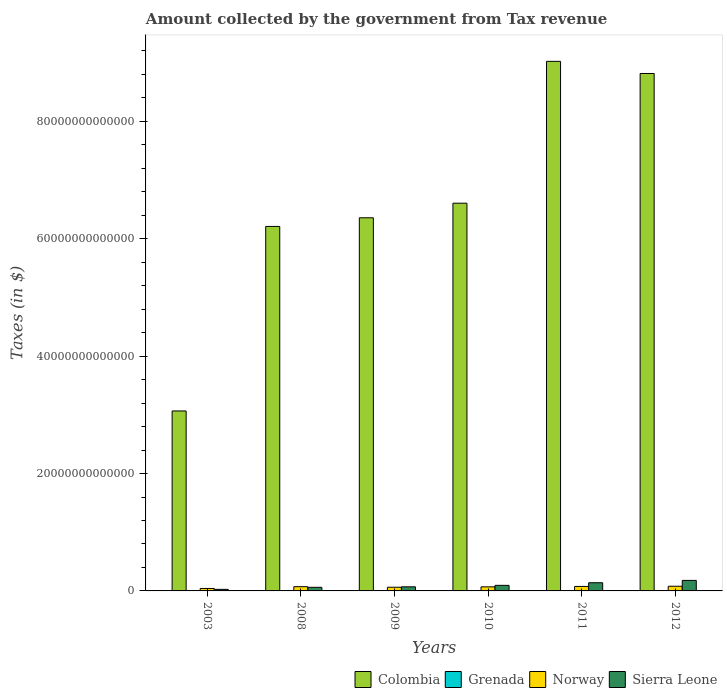How many different coloured bars are there?
Provide a succinct answer. 4. Are the number of bars per tick equal to the number of legend labels?
Keep it short and to the point. Yes. What is the amount collected by the government from tax revenue in Grenada in 2003?
Your answer should be very brief. 2.98e+08. Across all years, what is the maximum amount collected by the government from tax revenue in Norway?
Offer a terse response. 7.94e+11. Across all years, what is the minimum amount collected by the government from tax revenue in Norway?
Keep it short and to the point. 4.19e+11. What is the total amount collected by the government from tax revenue in Norway in the graph?
Your answer should be very brief. 4.02e+12. What is the difference between the amount collected by the government from tax revenue in Sierra Leone in 2008 and the amount collected by the government from tax revenue in Norway in 2009?
Keep it short and to the point. -1.29e+1. What is the average amount collected by the government from tax revenue in Colombia per year?
Your answer should be compact. 6.68e+13. In the year 2008, what is the difference between the amount collected by the government from tax revenue in Norway and amount collected by the government from tax revenue in Grenada?
Keep it short and to the point. 7.23e+11. In how many years, is the amount collected by the government from tax revenue in Sierra Leone greater than 84000000000000 $?
Offer a very short reply. 0. What is the ratio of the amount collected by the government from tax revenue in Grenada in 2008 to that in 2012?
Your answer should be very brief. 1.08. What is the difference between the highest and the second highest amount collected by the government from tax revenue in Grenada?
Your response must be concise. 3.06e+07. What is the difference between the highest and the lowest amount collected by the government from tax revenue in Colombia?
Give a very brief answer. 5.96e+13. Is the sum of the amount collected by the government from tax revenue in Grenada in 2009 and 2010 greater than the maximum amount collected by the government from tax revenue in Colombia across all years?
Provide a succinct answer. No. Is it the case that in every year, the sum of the amount collected by the government from tax revenue in Grenada and amount collected by the government from tax revenue in Sierra Leone is greater than the sum of amount collected by the government from tax revenue in Norway and amount collected by the government from tax revenue in Colombia?
Your answer should be compact. Yes. What does the 3rd bar from the left in 2009 represents?
Provide a succinct answer. Norway. How many bars are there?
Provide a succinct answer. 24. Are all the bars in the graph horizontal?
Make the answer very short. No. What is the difference between two consecutive major ticks on the Y-axis?
Offer a very short reply. 2.00e+13. Are the values on the major ticks of Y-axis written in scientific E-notation?
Make the answer very short. No. Does the graph contain grids?
Offer a terse response. No. How many legend labels are there?
Your response must be concise. 4. How are the legend labels stacked?
Make the answer very short. Horizontal. What is the title of the graph?
Offer a very short reply. Amount collected by the government from Tax revenue. What is the label or title of the Y-axis?
Your answer should be very brief. Taxes (in $). What is the Taxes (in $) of Colombia in 2003?
Ensure brevity in your answer.  3.07e+13. What is the Taxes (in $) in Grenada in 2003?
Ensure brevity in your answer.  2.98e+08. What is the Taxes (in $) of Norway in 2003?
Ensure brevity in your answer.  4.19e+11. What is the Taxes (in $) of Sierra Leone in 2003?
Provide a succinct answer. 2.68e+11. What is the Taxes (in $) of Colombia in 2008?
Your answer should be very brief. 6.21e+13. What is the Taxes (in $) of Grenada in 2008?
Offer a very short reply. 4.34e+08. What is the Taxes (in $) in Norway in 2008?
Keep it short and to the point. 7.24e+11. What is the Taxes (in $) of Sierra Leone in 2008?
Offer a very short reply. 6.13e+11. What is the Taxes (in $) in Colombia in 2009?
Keep it short and to the point. 6.36e+13. What is the Taxes (in $) of Grenada in 2009?
Give a very brief answer. 3.80e+08. What is the Taxes (in $) in Norway in 2009?
Your answer should be compact. 6.26e+11. What is the Taxes (in $) of Sierra Leone in 2009?
Your response must be concise. 6.99e+11. What is the Taxes (in $) in Colombia in 2010?
Offer a terse response. 6.61e+13. What is the Taxes (in $) in Grenada in 2010?
Keep it short and to the point. 3.90e+08. What is the Taxes (in $) in Norway in 2010?
Your response must be concise. 6.93e+11. What is the Taxes (in $) of Sierra Leone in 2010?
Ensure brevity in your answer.  9.48e+11. What is the Taxes (in $) of Colombia in 2011?
Offer a very short reply. 9.02e+13. What is the Taxes (in $) in Grenada in 2011?
Ensure brevity in your answer.  4.03e+08. What is the Taxes (in $) of Norway in 2011?
Offer a terse response. 7.65e+11. What is the Taxes (in $) in Sierra Leone in 2011?
Offer a very short reply. 1.39e+12. What is the Taxes (in $) of Colombia in 2012?
Ensure brevity in your answer.  8.82e+13. What is the Taxes (in $) in Grenada in 2012?
Make the answer very short. 4.03e+08. What is the Taxes (in $) in Norway in 2012?
Make the answer very short. 7.94e+11. What is the Taxes (in $) in Sierra Leone in 2012?
Your answer should be very brief. 1.79e+12. Across all years, what is the maximum Taxes (in $) in Colombia?
Offer a very short reply. 9.02e+13. Across all years, what is the maximum Taxes (in $) of Grenada?
Your answer should be compact. 4.34e+08. Across all years, what is the maximum Taxes (in $) in Norway?
Your response must be concise. 7.94e+11. Across all years, what is the maximum Taxes (in $) in Sierra Leone?
Provide a short and direct response. 1.79e+12. Across all years, what is the minimum Taxes (in $) in Colombia?
Make the answer very short. 3.07e+13. Across all years, what is the minimum Taxes (in $) of Grenada?
Make the answer very short. 2.98e+08. Across all years, what is the minimum Taxes (in $) of Norway?
Make the answer very short. 4.19e+11. Across all years, what is the minimum Taxes (in $) in Sierra Leone?
Offer a very short reply. 2.68e+11. What is the total Taxes (in $) of Colombia in the graph?
Your answer should be compact. 4.01e+14. What is the total Taxes (in $) in Grenada in the graph?
Your answer should be compact. 2.31e+09. What is the total Taxes (in $) of Norway in the graph?
Ensure brevity in your answer.  4.02e+12. What is the total Taxes (in $) in Sierra Leone in the graph?
Your answer should be compact. 5.72e+12. What is the difference between the Taxes (in $) of Colombia in 2003 and that in 2008?
Your answer should be compact. -3.14e+13. What is the difference between the Taxes (in $) in Grenada in 2003 and that in 2008?
Provide a succinct answer. -1.36e+08. What is the difference between the Taxes (in $) in Norway in 2003 and that in 2008?
Make the answer very short. -3.05e+11. What is the difference between the Taxes (in $) in Sierra Leone in 2003 and that in 2008?
Your response must be concise. -3.46e+11. What is the difference between the Taxes (in $) in Colombia in 2003 and that in 2009?
Your response must be concise. -3.29e+13. What is the difference between the Taxes (in $) in Grenada in 2003 and that in 2009?
Ensure brevity in your answer.  -8.16e+07. What is the difference between the Taxes (in $) of Norway in 2003 and that in 2009?
Your response must be concise. -2.07e+11. What is the difference between the Taxes (in $) of Sierra Leone in 2003 and that in 2009?
Offer a very short reply. -4.31e+11. What is the difference between the Taxes (in $) in Colombia in 2003 and that in 2010?
Keep it short and to the point. -3.54e+13. What is the difference between the Taxes (in $) of Grenada in 2003 and that in 2010?
Your answer should be compact. -9.16e+07. What is the difference between the Taxes (in $) of Norway in 2003 and that in 2010?
Your answer should be very brief. -2.74e+11. What is the difference between the Taxes (in $) of Sierra Leone in 2003 and that in 2010?
Your answer should be very brief. -6.80e+11. What is the difference between the Taxes (in $) in Colombia in 2003 and that in 2011?
Ensure brevity in your answer.  -5.96e+13. What is the difference between the Taxes (in $) in Grenada in 2003 and that in 2011?
Your response must be concise. -1.05e+08. What is the difference between the Taxes (in $) of Norway in 2003 and that in 2011?
Ensure brevity in your answer.  -3.46e+11. What is the difference between the Taxes (in $) in Sierra Leone in 2003 and that in 2011?
Give a very brief answer. -1.13e+12. What is the difference between the Taxes (in $) in Colombia in 2003 and that in 2012?
Your answer should be compact. -5.75e+13. What is the difference between the Taxes (in $) of Grenada in 2003 and that in 2012?
Offer a terse response. -1.05e+08. What is the difference between the Taxes (in $) of Norway in 2003 and that in 2012?
Your response must be concise. -3.75e+11. What is the difference between the Taxes (in $) of Sierra Leone in 2003 and that in 2012?
Your response must be concise. -1.53e+12. What is the difference between the Taxes (in $) in Colombia in 2008 and that in 2009?
Ensure brevity in your answer.  -1.47e+12. What is the difference between the Taxes (in $) of Grenada in 2008 and that in 2009?
Offer a terse response. 5.39e+07. What is the difference between the Taxes (in $) in Norway in 2008 and that in 2009?
Give a very brief answer. 9.71e+1. What is the difference between the Taxes (in $) of Sierra Leone in 2008 and that in 2009?
Your answer should be very brief. -8.54e+1. What is the difference between the Taxes (in $) of Colombia in 2008 and that in 2010?
Offer a terse response. -3.96e+12. What is the difference between the Taxes (in $) in Grenada in 2008 and that in 2010?
Your answer should be compact. 4.39e+07. What is the difference between the Taxes (in $) of Norway in 2008 and that in 2010?
Offer a very short reply. 3.08e+1. What is the difference between the Taxes (in $) of Sierra Leone in 2008 and that in 2010?
Offer a very short reply. -3.35e+11. What is the difference between the Taxes (in $) of Colombia in 2008 and that in 2011?
Offer a terse response. -2.81e+13. What is the difference between the Taxes (in $) of Grenada in 2008 and that in 2011?
Offer a very short reply. 3.08e+07. What is the difference between the Taxes (in $) of Norway in 2008 and that in 2011?
Make the answer very short. -4.12e+1. What is the difference between the Taxes (in $) of Sierra Leone in 2008 and that in 2011?
Provide a short and direct response. -7.80e+11. What is the difference between the Taxes (in $) in Colombia in 2008 and that in 2012?
Provide a succinct answer. -2.61e+13. What is the difference between the Taxes (in $) in Grenada in 2008 and that in 2012?
Offer a very short reply. 3.06e+07. What is the difference between the Taxes (in $) in Norway in 2008 and that in 2012?
Make the answer very short. -7.03e+1. What is the difference between the Taxes (in $) of Sierra Leone in 2008 and that in 2012?
Offer a terse response. -1.18e+12. What is the difference between the Taxes (in $) of Colombia in 2009 and that in 2010?
Make the answer very short. -2.49e+12. What is the difference between the Taxes (in $) of Grenada in 2009 and that in 2010?
Offer a terse response. -1.00e+07. What is the difference between the Taxes (in $) of Norway in 2009 and that in 2010?
Offer a very short reply. -6.63e+1. What is the difference between the Taxes (in $) of Sierra Leone in 2009 and that in 2010?
Ensure brevity in your answer.  -2.49e+11. What is the difference between the Taxes (in $) in Colombia in 2009 and that in 2011?
Offer a very short reply. -2.67e+13. What is the difference between the Taxes (in $) in Grenada in 2009 and that in 2011?
Keep it short and to the point. -2.31e+07. What is the difference between the Taxes (in $) in Norway in 2009 and that in 2011?
Offer a terse response. -1.38e+11. What is the difference between the Taxes (in $) of Sierra Leone in 2009 and that in 2011?
Offer a very short reply. -6.95e+11. What is the difference between the Taxes (in $) in Colombia in 2009 and that in 2012?
Give a very brief answer. -2.46e+13. What is the difference between the Taxes (in $) in Grenada in 2009 and that in 2012?
Ensure brevity in your answer.  -2.33e+07. What is the difference between the Taxes (in $) of Norway in 2009 and that in 2012?
Provide a short and direct response. -1.67e+11. What is the difference between the Taxes (in $) in Sierra Leone in 2009 and that in 2012?
Give a very brief answer. -1.09e+12. What is the difference between the Taxes (in $) in Colombia in 2010 and that in 2011?
Provide a short and direct response. -2.42e+13. What is the difference between the Taxes (in $) in Grenada in 2010 and that in 2011?
Offer a very short reply. -1.31e+07. What is the difference between the Taxes (in $) in Norway in 2010 and that in 2011?
Ensure brevity in your answer.  -7.20e+1. What is the difference between the Taxes (in $) of Sierra Leone in 2010 and that in 2011?
Keep it short and to the point. -4.45e+11. What is the difference between the Taxes (in $) of Colombia in 2010 and that in 2012?
Your answer should be compact. -2.21e+13. What is the difference between the Taxes (in $) in Grenada in 2010 and that in 2012?
Provide a short and direct response. -1.33e+07. What is the difference between the Taxes (in $) of Norway in 2010 and that in 2012?
Your answer should be very brief. -1.01e+11. What is the difference between the Taxes (in $) of Sierra Leone in 2010 and that in 2012?
Provide a short and direct response. -8.45e+11. What is the difference between the Taxes (in $) in Colombia in 2011 and that in 2012?
Give a very brief answer. 2.07e+12. What is the difference between the Taxes (in $) of Grenada in 2011 and that in 2012?
Make the answer very short. -2.00e+05. What is the difference between the Taxes (in $) of Norway in 2011 and that in 2012?
Your answer should be very brief. -2.91e+1. What is the difference between the Taxes (in $) of Sierra Leone in 2011 and that in 2012?
Provide a short and direct response. -4.00e+11. What is the difference between the Taxes (in $) of Colombia in 2003 and the Taxes (in $) of Grenada in 2008?
Your answer should be very brief. 3.07e+13. What is the difference between the Taxes (in $) in Colombia in 2003 and the Taxes (in $) in Norway in 2008?
Make the answer very short. 2.99e+13. What is the difference between the Taxes (in $) in Colombia in 2003 and the Taxes (in $) in Sierra Leone in 2008?
Provide a short and direct response. 3.00e+13. What is the difference between the Taxes (in $) of Grenada in 2003 and the Taxes (in $) of Norway in 2008?
Ensure brevity in your answer.  -7.23e+11. What is the difference between the Taxes (in $) in Grenada in 2003 and the Taxes (in $) in Sierra Leone in 2008?
Offer a terse response. -6.13e+11. What is the difference between the Taxes (in $) in Norway in 2003 and the Taxes (in $) in Sierra Leone in 2008?
Your response must be concise. -1.95e+11. What is the difference between the Taxes (in $) in Colombia in 2003 and the Taxes (in $) in Grenada in 2009?
Offer a very short reply. 3.07e+13. What is the difference between the Taxes (in $) of Colombia in 2003 and the Taxes (in $) of Norway in 2009?
Your answer should be very brief. 3.00e+13. What is the difference between the Taxes (in $) in Colombia in 2003 and the Taxes (in $) in Sierra Leone in 2009?
Give a very brief answer. 3.00e+13. What is the difference between the Taxes (in $) of Grenada in 2003 and the Taxes (in $) of Norway in 2009?
Offer a terse response. -6.26e+11. What is the difference between the Taxes (in $) of Grenada in 2003 and the Taxes (in $) of Sierra Leone in 2009?
Give a very brief answer. -6.99e+11. What is the difference between the Taxes (in $) in Norway in 2003 and the Taxes (in $) in Sierra Leone in 2009?
Your answer should be compact. -2.80e+11. What is the difference between the Taxes (in $) of Colombia in 2003 and the Taxes (in $) of Grenada in 2010?
Provide a succinct answer. 3.07e+13. What is the difference between the Taxes (in $) in Colombia in 2003 and the Taxes (in $) in Norway in 2010?
Your response must be concise. 3.00e+13. What is the difference between the Taxes (in $) of Colombia in 2003 and the Taxes (in $) of Sierra Leone in 2010?
Provide a succinct answer. 2.97e+13. What is the difference between the Taxes (in $) of Grenada in 2003 and the Taxes (in $) of Norway in 2010?
Keep it short and to the point. -6.92e+11. What is the difference between the Taxes (in $) of Grenada in 2003 and the Taxes (in $) of Sierra Leone in 2010?
Provide a succinct answer. -9.48e+11. What is the difference between the Taxes (in $) of Norway in 2003 and the Taxes (in $) of Sierra Leone in 2010?
Offer a terse response. -5.29e+11. What is the difference between the Taxes (in $) in Colombia in 2003 and the Taxes (in $) in Grenada in 2011?
Your answer should be very brief. 3.07e+13. What is the difference between the Taxes (in $) of Colombia in 2003 and the Taxes (in $) of Norway in 2011?
Your response must be concise. 2.99e+13. What is the difference between the Taxes (in $) of Colombia in 2003 and the Taxes (in $) of Sierra Leone in 2011?
Give a very brief answer. 2.93e+13. What is the difference between the Taxes (in $) of Grenada in 2003 and the Taxes (in $) of Norway in 2011?
Keep it short and to the point. -7.64e+11. What is the difference between the Taxes (in $) of Grenada in 2003 and the Taxes (in $) of Sierra Leone in 2011?
Give a very brief answer. -1.39e+12. What is the difference between the Taxes (in $) of Norway in 2003 and the Taxes (in $) of Sierra Leone in 2011?
Your answer should be very brief. -9.75e+11. What is the difference between the Taxes (in $) in Colombia in 2003 and the Taxes (in $) in Grenada in 2012?
Provide a short and direct response. 3.07e+13. What is the difference between the Taxes (in $) in Colombia in 2003 and the Taxes (in $) in Norway in 2012?
Your answer should be compact. 2.99e+13. What is the difference between the Taxes (in $) in Colombia in 2003 and the Taxes (in $) in Sierra Leone in 2012?
Provide a succinct answer. 2.89e+13. What is the difference between the Taxes (in $) of Grenada in 2003 and the Taxes (in $) of Norway in 2012?
Keep it short and to the point. -7.93e+11. What is the difference between the Taxes (in $) of Grenada in 2003 and the Taxes (in $) of Sierra Leone in 2012?
Keep it short and to the point. -1.79e+12. What is the difference between the Taxes (in $) of Norway in 2003 and the Taxes (in $) of Sierra Leone in 2012?
Your response must be concise. -1.37e+12. What is the difference between the Taxes (in $) in Colombia in 2008 and the Taxes (in $) in Grenada in 2009?
Provide a short and direct response. 6.21e+13. What is the difference between the Taxes (in $) of Colombia in 2008 and the Taxes (in $) of Norway in 2009?
Provide a succinct answer. 6.15e+13. What is the difference between the Taxes (in $) in Colombia in 2008 and the Taxes (in $) in Sierra Leone in 2009?
Offer a terse response. 6.14e+13. What is the difference between the Taxes (in $) in Grenada in 2008 and the Taxes (in $) in Norway in 2009?
Provide a short and direct response. -6.26e+11. What is the difference between the Taxes (in $) of Grenada in 2008 and the Taxes (in $) of Sierra Leone in 2009?
Offer a very short reply. -6.98e+11. What is the difference between the Taxes (in $) in Norway in 2008 and the Taxes (in $) in Sierra Leone in 2009?
Provide a succinct answer. 2.46e+1. What is the difference between the Taxes (in $) in Colombia in 2008 and the Taxes (in $) in Grenada in 2010?
Offer a very short reply. 6.21e+13. What is the difference between the Taxes (in $) in Colombia in 2008 and the Taxes (in $) in Norway in 2010?
Your answer should be compact. 6.14e+13. What is the difference between the Taxes (in $) of Colombia in 2008 and the Taxes (in $) of Sierra Leone in 2010?
Provide a short and direct response. 6.12e+13. What is the difference between the Taxes (in $) in Grenada in 2008 and the Taxes (in $) in Norway in 2010?
Provide a succinct answer. -6.92e+11. What is the difference between the Taxes (in $) of Grenada in 2008 and the Taxes (in $) of Sierra Leone in 2010?
Provide a short and direct response. -9.48e+11. What is the difference between the Taxes (in $) of Norway in 2008 and the Taxes (in $) of Sierra Leone in 2010?
Make the answer very short. -2.25e+11. What is the difference between the Taxes (in $) of Colombia in 2008 and the Taxes (in $) of Grenada in 2011?
Your response must be concise. 6.21e+13. What is the difference between the Taxes (in $) of Colombia in 2008 and the Taxes (in $) of Norway in 2011?
Offer a terse response. 6.13e+13. What is the difference between the Taxes (in $) of Colombia in 2008 and the Taxes (in $) of Sierra Leone in 2011?
Offer a very short reply. 6.07e+13. What is the difference between the Taxes (in $) of Grenada in 2008 and the Taxes (in $) of Norway in 2011?
Offer a terse response. -7.64e+11. What is the difference between the Taxes (in $) in Grenada in 2008 and the Taxes (in $) in Sierra Leone in 2011?
Your answer should be compact. -1.39e+12. What is the difference between the Taxes (in $) of Norway in 2008 and the Taxes (in $) of Sierra Leone in 2011?
Your answer should be very brief. -6.70e+11. What is the difference between the Taxes (in $) in Colombia in 2008 and the Taxes (in $) in Grenada in 2012?
Provide a short and direct response. 6.21e+13. What is the difference between the Taxes (in $) in Colombia in 2008 and the Taxes (in $) in Norway in 2012?
Provide a short and direct response. 6.13e+13. What is the difference between the Taxes (in $) of Colombia in 2008 and the Taxes (in $) of Sierra Leone in 2012?
Your answer should be very brief. 6.03e+13. What is the difference between the Taxes (in $) in Grenada in 2008 and the Taxes (in $) in Norway in 2012?
Give a very brief answer. -7.93e+11. What is the difference between the Taxes (in $) of Grenada in 2008 and the Taxes (in $) of Sierra Leone in 2012?
Provide a short and direct response. -1.79e+12. What is the difference between the Taxes (in $) of Norway in 2008 and the Taxes (in $) of Sierra Leone in 2012?
Your response must be concise. -1.07e+12. What is the difference between the Taxes (in $) of Colombia in 2009 and the Taxes (in $) of Grenada in 2010?
Offer a terse response. 6.36e+13. What is the difference between the Taxes (in $) of Colombia in 2009 and the Taxes (in $) of Norway in 2010?
Provide a succinct answer. 6.29e+13. What is the difference between the Taxes (in $) of Colombia in 2009 and the Taxes (in $) of Sierra Leone in 2010?
Make the answer very short. 6.26e+13. What is the difference between the Taxes (in $) of Grenada in 2009 and the Taxes (in $) of Norway in 2010?
Provide a short and direct response. -6.92e+11. What is the difference between the Taxes (in $) in Grenada in 2009 and the Taxes (in $) in Sierra Leone in 2010?
Your response must be concise. -9.48e+11. What is the difference between the Taxes (in $) of Norway in 2009 and the Taxes (in $) of Sierra Leone in 2010?
Ensure brevity in your answer.  -3.22e+11. What is the difference between the Taxes (in $) of Colombia in 2009 and the Taxes (in $) of Grenada in 2011?
Give a very brief answer. 6.36e+13. What is the difference between the Taxes (in $) of Colombia in 2009 and the Taxes (in $) of Norway in 2011?
Keep it short and to the point. 6.28e+13. What is the difference between the Taxes (in $) of Colombia in 2009 and the Taxes (in $) of Sierra Leone in 2011?
Give a very brief answer. 6.22e+13. What is the difference between the Taxes (in $) in Grenada in 2009 and the Taxes (in $) in Norway in 2011?
Ensure brevity in your answer.  -7.64e+11. What is the difference between the Taxes (in $) of Grenada in 2009 and the Taxes (in $) of Sierra Leone in 2011?
Give a very brief answer. -1.39e+12. What is the difference between the Taxes (in $) of Norway in 2009 and the Taxes (in $) of Sierra Leone in 2011?
Give a very brief answer. -7.67e+11. What is the difference between the Taxes (in $) of Colombia in 2009 and the Taxes (in $) of Grenada in 2012?
Keep it short and to the point. 6.36e+13. What is the difference between the Taxes (in $) of Colombia in 2009 and the Taxes (in $) of Norway in 2012?
Ensure brevity in your answer.  6.28e+13. What is the difference between the Taxes (in $) of Colombia in 2009 and the Taxes (in $) of Sierra Leone in 2012?
Your response must be concise. 6.18e+13. What is the difference between the Taxes (in $) in Grenada in 2009 and the Taxes (in $) in Norway in 2012?
Provide a short and direct response. -7.93e+11. What is the difference between the Taxes (in $) of Grenada in 2009 and the Taxes (in $) of Sierra Leone in 2012?
Provide a succinct answer. -1.79e+12. What is the difference between the Taxes (in $) in Norway in 2009 and the Taxes (in $) in Sierra Leone in 2012?
Offer a very short reply. -1.17e+12. What is the difference between the Taxes (in $) of Colombia in 2010 and the Taxes (in $) of Grenada in 2011?
Offer a terse response. 6.61e+13. What is the difference between the Taxes (in $) in Colombia in 2010 and the Taxes (in $) in Norway in 2011?
Give a very brief answer. 6.53e+13. What is the difference between the Taxes (in $) in Colombia in 2010 and the Taxes (in $) in Sierra Leone in 2011?
Your response must be concise. 6.47e+13. What is the difference between the Taxes (in $) in Grenada in 2010 and the Taxes (in $) in Norway in 2011?
Your response must be concise. -7.64e+11. What is the difference between the Taxes (in $) in Grenada in 2010 and the Taxes (in $) in Sierra Leone in 2011?
Offer a very short reply. -1.39e+12. What is the difference between the Taxes (in $) of Norway in 2010 and the Taxes (in $) of Sierra Leone in 2011?
Keep it short and to the point. -7.01e+11. What is the difference between the Taxes (in $) in Colombia in 2010 and the Taxes (in $) in Grenada in 2012?
Offer a terse response. 6.61e+13. What is the difference between the Taxes (in $) of Colombia in 2010 and the Taxes (in $) of Norway in 2012?
Give a very brief answer. 6.53e+13. What is the difference between the Taxes (in $) in Colombia in 2010 and the Taxes (in $) in Sierra Leone in 2012?
Offer a very short reply. 6.43e+13. What is the difference between the Taxes (in $) of Grenada in 2010 and the Taxes (in $) of Norway in 2012?
Make the answer very short. -7.93e+11. What is the difference between the Taxes (in $) in Grenada in 2010 and the Taxes (in $) in Sierra Leone in 2012?
Your answer should be compact. -1.79e+12. What is the difference between the Taxes (in $) in Norway in 2010 and the Taxes (in $) in Sierra Leone in 2012?
Your response must be concise. -1.10e+12. What is the difference between the Taxes (in $) in Colombia in 2011 and the Taxes (in $) in Grenada in 2012?
Ensure brevity in your answer.  9.02e+13. What is the difference between the Taxes (in $) in Colombia in 2011 and the Taxes (in $) in Norway in 2012?
Your answer should be very brief. 8.94e+13. What is the difference between the Taxes (in $) of Colombia in 2011 and the Taxes (in $) of Sierra Leone in 2012?
Give a very brief answer. 8.84e+13. What is the difference between the Taxes (in $) of Grenada in 2011 and the Taxes (in $) of Norway in 2012?
Keep it short and to the point. -7.93e+11. What is the difference between the Taxes (in $) of Grenada in 2011 and the Taxes (in $) of Sierra Leone in 2012?
Offer a terse response. -1.79e+12. What is the difference between the Taxes (in $) of Norway in 2011 and the Taxes (in $) of Sierra Leone in 2012?
Make the answer very short. -1.03e+12. What is the average Taxes (in $) in Colombia per year?
Make the answer very short. 6.68e+13. What is the average Taxes (in $) of Grenada per year?
Provide a short and direct response. 3.85e+08. What is the average Taxes (in $) of Norway per year?
Give a very brief answer. 6.70e+11. What is the average Taxes (in $) in Sierra Leone per year?
Keep it short and to the point. 9.53e+11. In the year 2003, what is the difference between the Taxes (in $) of Colombia and Taxes (in $) of Grenada?
Offer a terse response. 3.07e+13. In the year 2003, what is the difference between the Taxes (in $) of Colombia and Taxes (in $) of Norway?
Ensure brevity in your answer.  3.02e+13. In the year 2003, what is the difference between the Taxes (in $) in Colombia and Taxes (in $) in Sierra Leone?
Make the answer very short. 3.04e+13. In the year 2003, what is the difference between the Taxes (in $) of Grenada and Taxes (in $) of Norway?
Your answer should be very brief. -4.19e+11. In the year 2003, what is the difference between the Taxes (in $) of Grenada and Taxes (in $) of Sierra Leone?
Keep it short and to the point. -2.68e+11. In the year 2003, what is the difference between the Taxes (in $) in Norway and Taxes (in $) in Sierra Leone?
Offer a very short reply. 1.51e+11. In the year 2008, what is the difference between the Taxes (in $) of Colombia and Taxes (in $) of Grenada?
Ensure brevity in your answer.  6.21e+13. In the year 2008, what is the difference between the Taxes (in $) in Colombia and Taxes (in $) in Norway?
Your response must be concise. 6.14e+13. In the year 2008, what is the difference between the Taxes (in $) of Colombia and Taxes (in $) of Sierra Leone?
Your response must be concise. 6.15e+13. In the year 2008, what is the difference between the Taxes (in $) of Grenada and Taxes (in $) of Norway?
Your answer should be compact. -7.23e+11. In the year 2008, what is the difference between the Taxes (in $) in Grenada and Taxes (in $) in Sierra Leone?
Offer a very short reply. -6.13e+11. In the year 2008, what is the difference between the Taxes (in $) of Norway and Taxes (in $) of Sierra Leone?
Make the answer very short. 1.10e+11. In the year 2009, what is the difference between the Taxes (in $) in Colombia and Taxes (in $) in Grenada?
Offer a terse response. 6.36e+13. In the year 2009, what is the difference between the Taxes (in $) of Colombia and Taxes (in $) of Norway?
Give a very brief answer. 6.29e+13. In the year 2009, what is the difference between the Taxes (in $) in Colombia and Taxes (in $) in Sierra Leone?
Provide a short and direct response. 6.29e+13. In the year 2009, what is the difference between the Taxes (in $) of Grenada and Taxes (in $) of Norway?
Offer a terse response. -6.26e+11. In the year 2009, what is the difference between the Taxes (in $) of Grenada and Taxes (in $) of Sierra Leone?
Your answer should be very brief. -6.98e+11. In the year 2009, what is the difference between the Taxes (in $) of Norway and Taxes (in $) of Sierra Leone?
Give a very brief answer. -7.25e+1. In the year 2010, what is the difference between the Taxes (in $) in Colombia and Taxes (in $) in Grenada?
Offer a very short reply. 6.61e+13. In the year 2010, what is the difference between the Taxes (in $) of Colombia and Taxes (in $) of Norway?
Your answer should be compact. 6.54e+13. In the year 2010, what is the difference between the Taxes (in $) of Colombia and Taxes (in $) of Sierra Leone?
Ensure brevity in your answer.  6.51e+13. In the year 2010, what is the difference between the Taxes (in $) of Grenada and Taxes (in $) of Norway?
Make the answer very short. -6.92e+11. In the year 2010, what is the difference between the Taxes (in $) in Grenada and Taxes (in $) in Sierra Leone?
Offer a very short reply. -9.48e+11. In the year 2010, what is the difference between the Taxes (in $) in Norway and Taxes (in $) in Sierra Leone?
Your answer should be very brief. -2.56e+11. In the year 2011, what is the difference between the Taxes (in $) in Colombia and Taxes (in $) in Grenada?
Offer a very short reply. 9.02e+13. In the year 2011, what is the difference between the Taxes (in $) of Colombia and Taxes (in $) of Norway?
Your response must be concise. 8.95e+13. In the year 2011, what is the difference between the Taxes (in $) of Colombia and Taxes (in $) of Sierra Leone?
Your answer should be very brief. 8.88e+13. In the year 2011, what is the difference between the Taxes (in $) in Grenada and Taxes (in $) in Norway?
Make the answer very short. -7.64e+11. In the year 2011, what is the difference between the Taxes (in $) of Grenada and Taxes (in $) of Sierra Leone?
Provide a short and direct response. -1.39e+12. In the year 2011, what is the difference between the Taxes (in $) of Norway and Taxes (in $) of Sierra Leone?
Provide a succinct answer. -6.29e+11. In the year 2012, what is the difference between the Taxes (in $) of Colombia and Taxes (in $) of Grenada?
Give a very brief answer. 8.82e+13. In the year 2012, what is the difference between the Taxes (in $) in Colombia and Taxes (in $) in Norway?
Make the answer very short. 8.74e+13. In the year 2012, what is the difference between the Taxes (in $) in Colombia and Taxes (in $) in Sierra Leone?
Keep it short and to the point. 8.64e+13. In the year 2012, what is the difference between the Taxes (in $) of Grenada and Taxes (in $) of Norway?
Your answer should be compact. -7.93e+11. In the year 2012, what is the difference between the Taxes (in $) in Grenada and Taxes (in $) in Sierra Leone?
Offer a terse response. -1.79e+12. In the year 2012, what is the difference between the Taxes (in $) of Norway and Taxes (in $) of Sierra Leone?
Make the answer very short. -9.99e+11. What is the ratio of the Taxes (in $) of Colombia in 2003 to that in 2008?
Make the answer very short. 0.49. What is the ratio of the Taxes (in $) of Grenada in 2003 to that in 2008?
Make the answer very short. 0.69. What is the ratio of the Taxes (in $) in Norway in 2003 to that in 2008?
Your answer should be very brief. 0.58. What is the ratio of the Taxes (in $) of Sierra Leone in 2003 to that in 2008?
Give a very brief answer. 0.44. What is the ratio of the Taxes (in $) in Colombia in 2003 to that in 2009?
Ensure brevity in your answer.  0.48. What is the ratio of the Taxes (in $) in Grenada in 2003 to that in 2009?
Offer a terse response. 0.79. What is the ratio of the Taxes (in $) in Norway in 2003 to that in 2009?
Provide a short and direct response. 0.67. What is the ratio of the Taxes (in $) of Sierra Leone in 2003 to that in 2009?
Offer a very short reply. 0.38. What is the ratio of the Taxes (in $) of Colombia in 2003 to that in 2010?
Your response must be concise. 0.46. What is the ratio of the Taxes (in $) in Grenada in 2003 to that in 2010?
Make the answer very short. 0.77. What is the ratio of the Taxes (in $) of Norway in 2003 to that in 2010?
Offer a terse response. 0.6. What is the ratio of the Taxes (in $) of Sierra Leone in 2003 to that in 2010?
Keep it short and to the point. 0.28. What is the ratio of the Taxes (in $) of Colombia in 2003 to that in 2011?
Your answer should be very brief. 0.34. What is the ratio of the Taxes (in $) of Grenada in 2003 to that in 2011?
Offer a very short reply. 0.74. What is the ratio of the Taxes (in $) in Norway in 2003 to that in 2011?
Provide a short and direct response. 0.55. What is the ratio of the Taxes (in $) in Sierra Leone in 2003 to that in 2011?
Give a very brief answer. 0.19. What is the ratio of the Taxes (in $) in Colombia in 2003 to that in 2012?
Offer a terse response. 0.35. What is the ratio of the Taxes (in $) in Grenada in 2003 to that in 2012?
Your answer should be very brief. 0.74. What is the ratio of the Taxes (in $) in Norway in 2003 to that in 2012?
Your response must be concise. 0.53. What is the ratio of the Taxes (in $) of Sierra Leone in 2003 to that in 2012?
Keep it short and to the point. 0.15. What is the ratio of the Taxes (in $) of Colombia in 2008 to that in 2009?
Keep it short and to the point. 0.98. What is the ratio of the Taxes (in $) in Grenada in 2008 to that in 2009?
Your answer should be very brief. 1.14. What is the ratio of the Taxes (in $) in Norway in 2008 to that in 2009?
Your response must be concise. 1.16. What is the ratio of the Taxes (in $) in Sierra Leone in 2008 to that in 2009?
Give a very brief answer. 0.88. What is the ratio of the Taxes (in $) of Colombia in 2008 to that in 2010?
Provide a short and direct response. 0.94. What is the ratio of the Taxes (in $) of Grenada in 2008 to that in 2010?
Your answer should be very brief. 1.11. What is the ratio of the Taxes (in $) of Norway in 2008 to that in 2010?
Your response must be concise. 1.04. What is the ratio of the Taxes (in $) in Sierra Leone in 2008 to that in 2010?
Your answer should be compact. 0.65. What is the ratio of the Taxes (in $) of Colombia in 2008 to that in 2011?
Give a very brief answer. 0.69. What is the ratio of the Taxes (in $) of Grenada in 2008 to that in 2011?
Ensure brevity in your answer.  1.08. What is the ratio of the Taxes (in $) of Norway in 2008 to that in 2011?
Your response must be concise. 0.95. What is the ratio of the Taxes (in $) of Sierra Leone in 2008 to that in 2011?
Offer a terse response. 0.44. What is the ratio of the Taxes (in $) of Colombia in 2008 to that in 2012?
Ensure brevity in your answer.  0.7. What is the ratio of the Taxes (in $) in Grenada in 2008 to that in 2012?
Give a very brief answer. 1.08. What is the ratio of the Taxes (in $) in Norway in 2008 to that in 2012?
Your answer should be very brief. 0.91. What is the ratio of the Taxes (in $) in Sierra Leone in 2008 to that in 2012?
Your response must be concise. 0.34. What is the ratio of the Taxes (in $) in Colombia in 2009 to that in 2010?
Your answer should be compact. 0.96. What is the ratio of the Taxes (in $) in Grenada in 2009 to that in 2010?
Offer a terse response. 0.97. What is the ratio of the Taxes (in $) in Norway in 2009 to that in 2010?
Your answer should be compact. 0.9. What is the ratio of the Taxes (in $) in Sierra Leone in 2009 to that in 2010?
Your answer should be compact. 0.74. What is the ratio of the Taxes (in $) in Colombia in 2009 to that in 2011?
Your answer should be very brief. 0.7. What is the ratio of the Taxes (in $) in Grenada in 2009 to that in 2011?
Offer a terse response. 0.94. What is the ratio of the Taxes (in $) of Norway in 2009 to that in 2011?
Provide a succinct answer. 0.82. What is the ratio of the Taxes (in $) in Sierra Leone in 2009 to that in 2011?
Make the answer very short. 0.5. What is the ratio of the Taxes (in $) of Colombia in 2009 to that in 2012?
Offer a terse response. 0.72. What is the ratio of the Taxes (in $) of Grenada in 2009 to that in 2012?
Keep it short and to the point. 0.94. What is the ratio of the Taxes (in $) in Norway in 2009 to that in 2012?
Offer a very short reply. 0.79. What is the ratio of the Taxes (in $) in Sierra Leone in 2009 to that in 2012?
Provide a succinct answer. 0.39. What is the ratio of the Taxes (in $) of Colombia in 2010 to that in 2011?
Offer a very short reply. 0.73. What is the ratio of the Taxes (in $) in Grenada in 2010 to that in 2011?
Give a very brief answer. 0.97. What is the ratio of the Taxes (in $) of Norway in 2010 to that in 2011?
Ensure brevity in your answer.  0.91. What is the ratio of the Taxes (in $) of Sierra Leone in 2010 to that in 2011?
Provide a short and direct response. 0.68. What is the ratio of the Taxes (in $) in Colombia in 2010 to that in 2012?
Your response must be concise. 0.75. What is the ratio of the Taxes (in $) in Norway in 2010 to that in 2012?
Give a very brief answer. 0.87. What is the ratio of the Taxes (in $) of Sierra Leone in 2010 to that in 2012?
Provide a succinct answer. 0.53. What is the ratio of the Taxes (in $) in Colombia in 2011 to that in 2012?
Keep it short and to the point. 1.02. What is the ratio of the Taxes (in $) of Norway in 2011 to that in 2012?
Keep it short and to the point. 0.96. What is the ratio of the Taxes (in $) of Sierra Leone in 2011 to that in 2012?
Offer a terse response. 0.78. What is the difference between the highest and the second highest Taxes (in $) of Colombia?
Provide a succinct answer. 2.07e+12. What is the difference between the highest and the second highest Taxes (in $) of Grenada?
Offer a terse response. 3.06e+07. What is the difference between the highest and the second highest Taxes (in $) of Norway?
Offer a terse response. 2.91e+1. What is the difference between the highest and the second highest Taxes (in $) in Sierra Leone?
Ensure brevity in your answer.  4.00e+11. What is the difference between the highest and the lowest Taxes (in $) in Colombia?
Keep it short and to the point. 5.96e+13. What is the difference between the highest and the lowest Taxes (in $) of Grenada?
Keep it short and to the point. 1.36e+08. What is the difference between the highest and the lowest Taxes (in $) of Norway?
Provide a succinct answer. 3.75e+11. What is the difference between the highest and the lowest Taxes (in $) of Sierra Leone?
Give a very brief answer. 1.53e+12. 